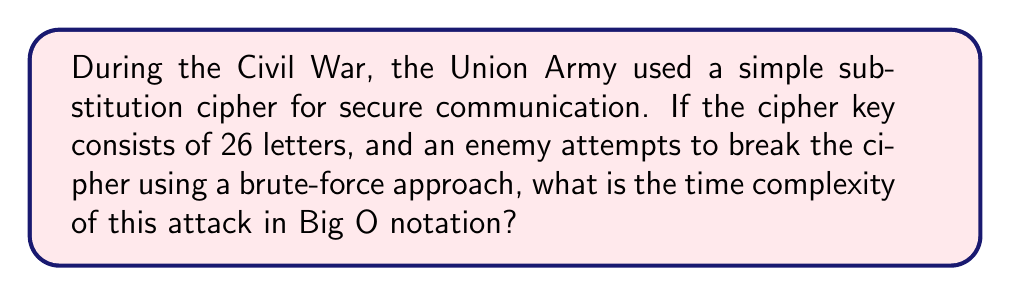Teach me how to tackle this problem. To understand the computational complexity of breaking this cipher, let's break down the problem:

1. The cipher key consists of 26 letters, which can be arranged in any order.

2. The number of possible arrangements is equal to the number of permutations of 26 letters, which is 26! (26 factorial).

3. A brute-force attack would need to try all possible arrangements until the correct one is found.

4. In the worst-case scenario, all permutations would need to be checked.

5. The time complexity of generating and checking each permutation is constant, let's call it $c$.

6. Therefore, the total time complexity is proportional to $26! \times c$.

7. In Big O notation, we ignore constant factors and lower-order terms. 26! is a constant (albeit a very large one), so we can simplify this to O(1).

However, it's important to note that while the time complexity is technically O(1), the actual computation time would be enormous due to the magnitude of 26!. This is why even simple substitution ciphers were effective for a time, despite their vulnerability to frequency analysis.

For context, 26! is approximately $4.03 \times 10^{26}$. If a computer could check one trillion ($10^{12}$) permutations per second, it would still take about 12.8 billion years to check all possibilities.

This example illustrates why modern cryptographic algorithms use much larger key spaces and more complex algorithms to achieve security.
Answer: O(1) 